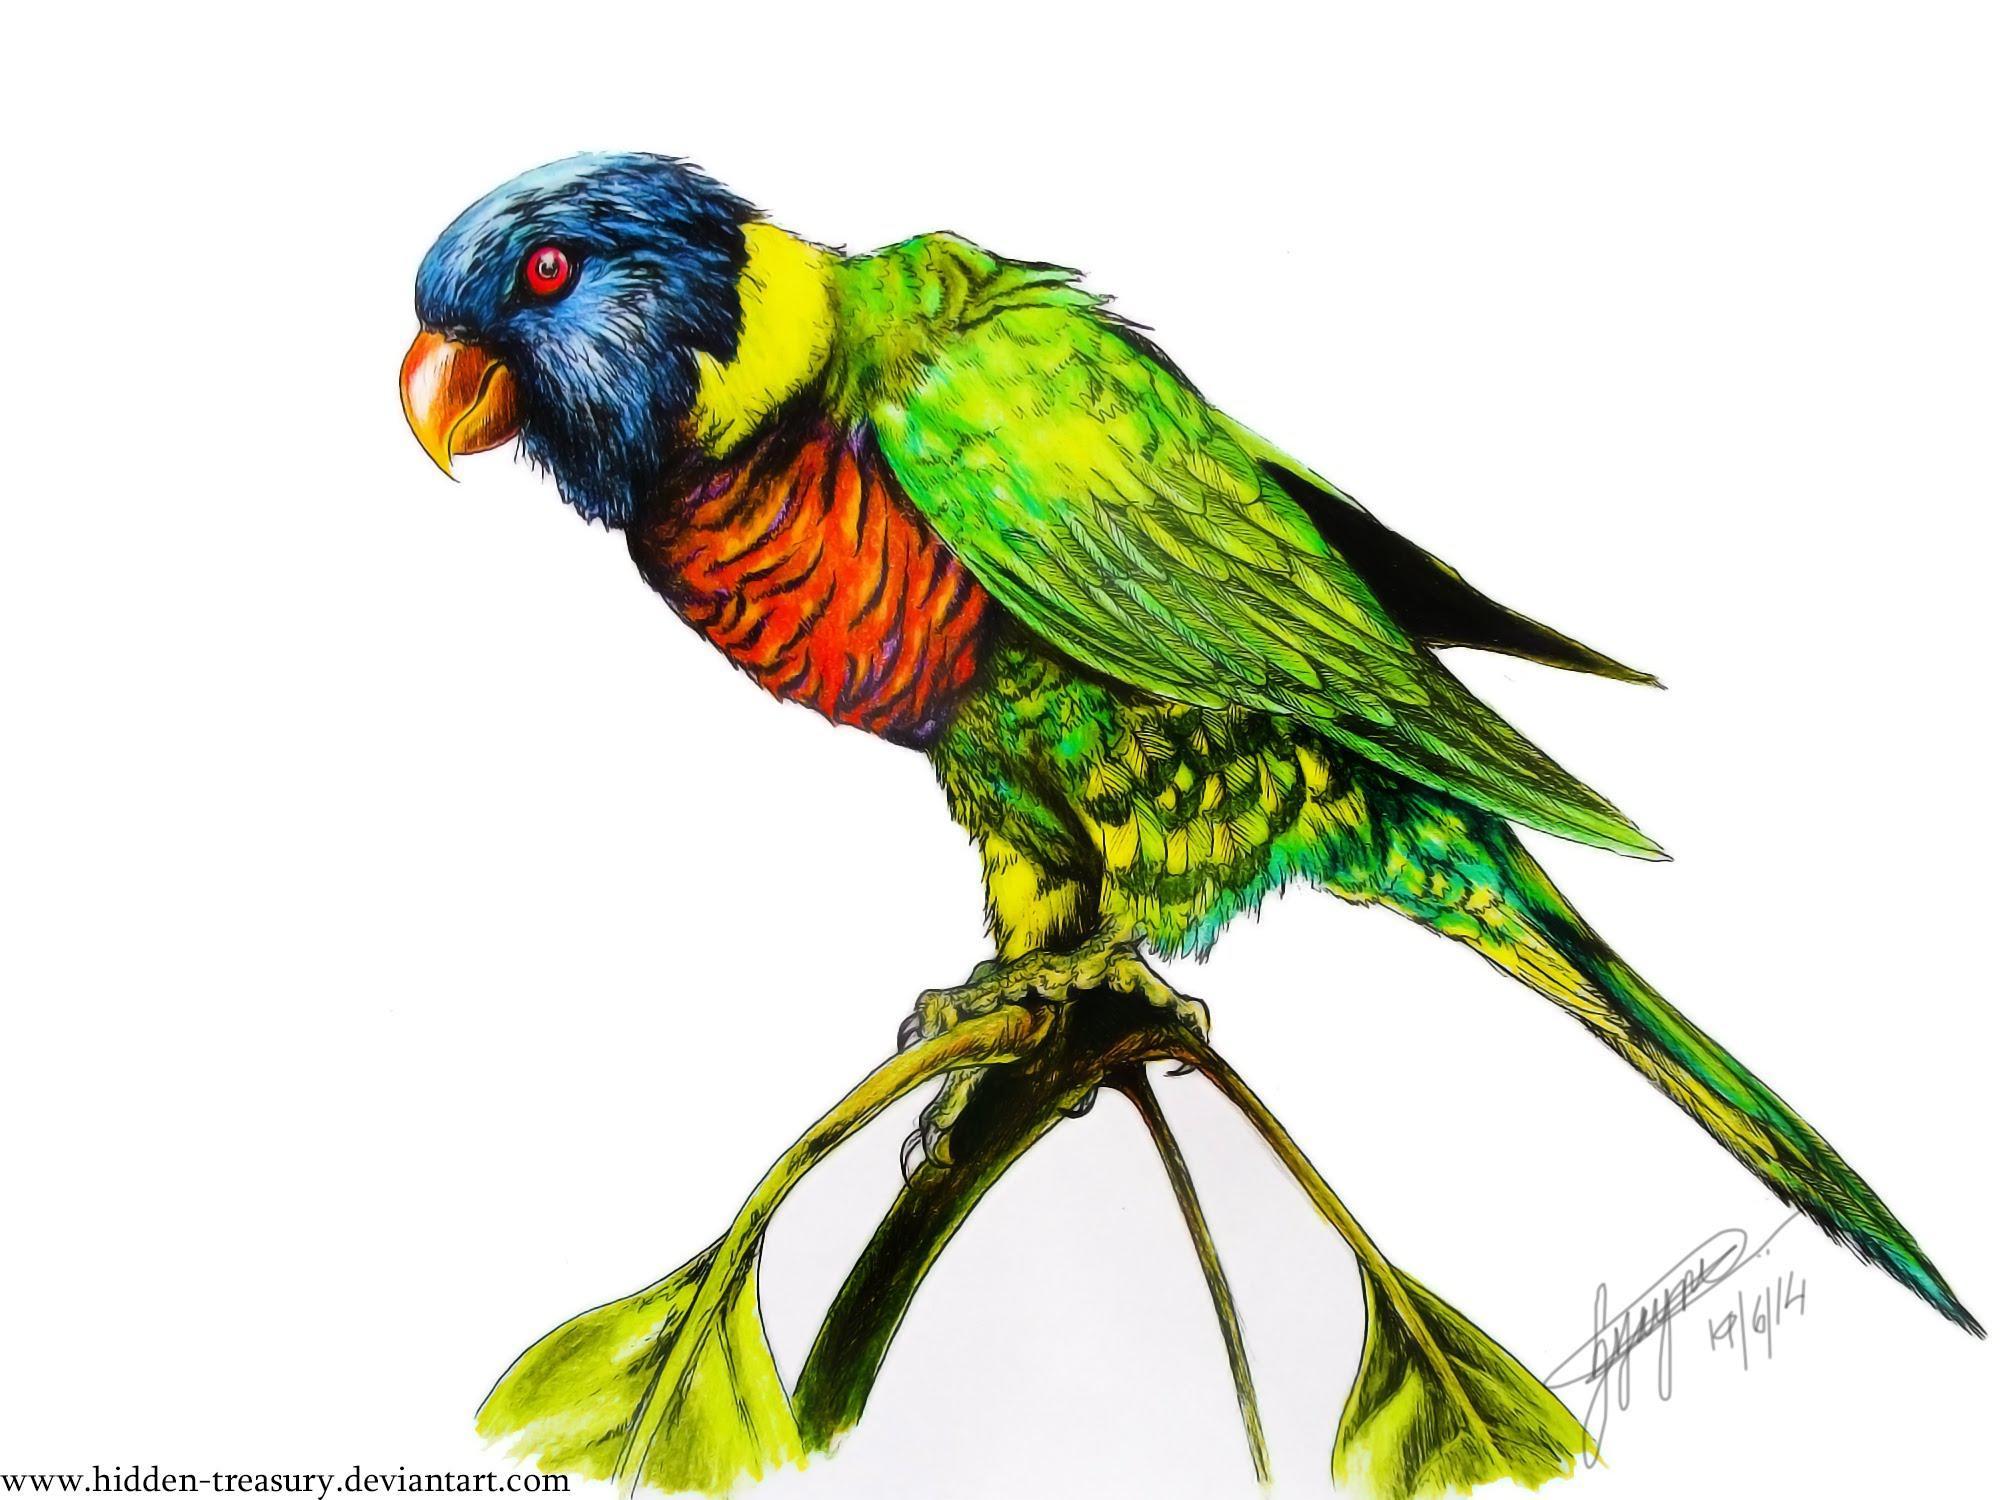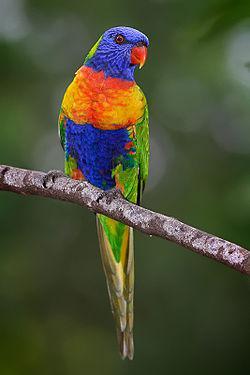The first image is the image on the left, the second image is the image on the right. Assess this claim about the two images: "The parrots in the two images are looking toward each other.". Correct or not? Answer yes or no. No. The first image is the image on the left, the second image is the image on the right. For the images displayed, is the sentence "A single bird perches on a branch with leaves on it." factually correct? Answer yes or no. Yes. 